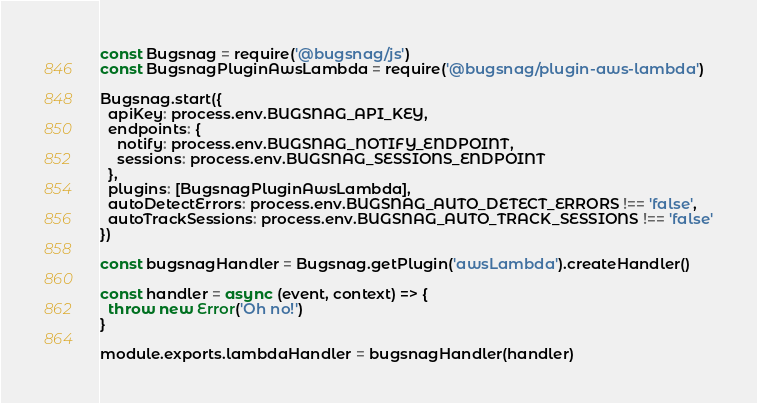<code> <loc_0><loc_0><loc_500><loc_500><_JavaScript_>const Bugsnag = require('@bugsnag/js')
const BugsnagPluginAwsLambda = require('@bugsnag/plugin-aws-lambda')

Bugsnag.start({
  apiKey: process.env.BUGSNAG_API_KEY,
  endpoints: {
    notify: process.env.BUGSNAG_NOTIFY_ENDPOINT,
    sessions: process.env.BUGSNAG_SESSIONS_ENDPOINT
  },
  plugins: [BugsnagPluginAwsLambda],
  autoDetectErrors: process.env.BUGSNAG_AUTO_DETECT_ERRORS !== 'false',
  autoTrackSessions: process.env.BUGSNAG_AUTO_TRACK_SESSIONS !== 'false'
})

const bugsnagHandler = Bugsnag.getPlugin('awsLambda').createHandler()

const handler = async (event, context) => {
  throw new Error('Oh no!')
}

module.exports.lambdaHandler = bugsnagHandler(handler)
</code> 